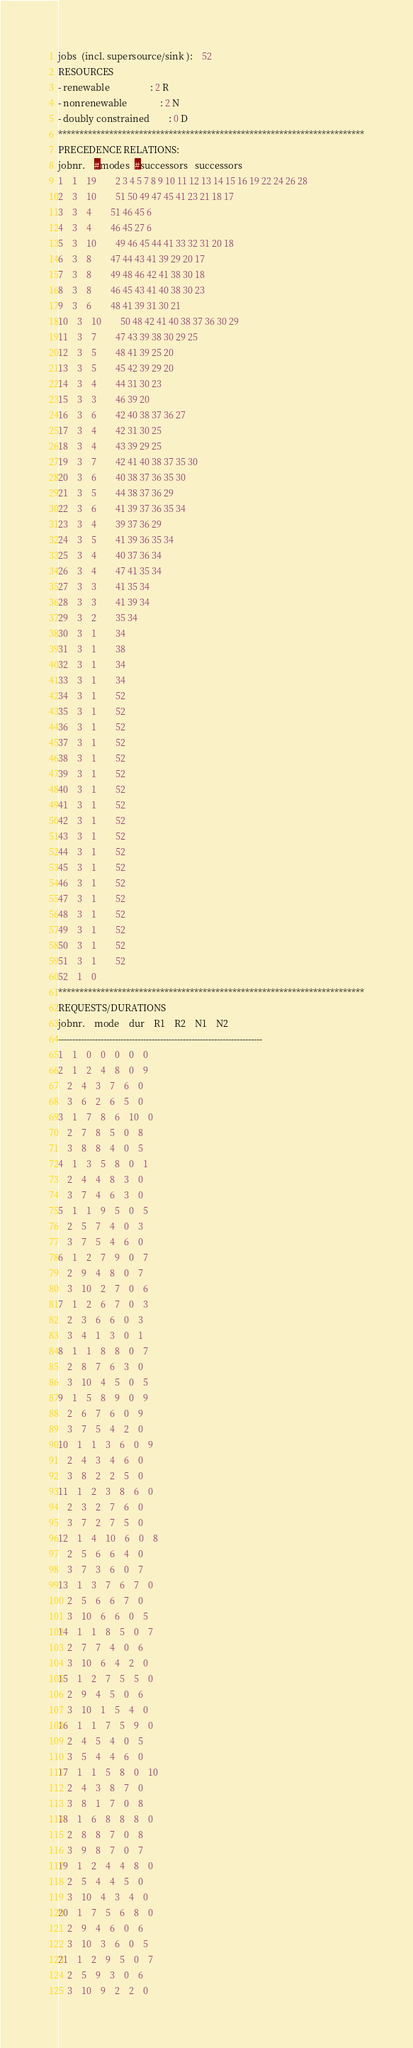<code> <loc_0><loc_0><loc_500><loc_500><_ObjectiveC_>jobs  (incl. supersource/sink ):	52
RESOURCES
- renewable                 : 2 R
- nonrenewable              : 2 N
- doubly constrained        : 0 D
************************************************************************
PRECEDENCE RELATIONS:
jobnr.    #modes  #successors   successors
1	1	19		2 3 4 5 7 8 9 10 11 12 13 14 15 16 19 22 24 26 28 
2	3	10		51 50 49 47 45 41 23 21 18 17 
3	3	4		51 46 45 6 
4	3	4		46 45 27 6 
5	3	10		49 46 45 44 41 33 32 31 20 18 
6	3	8		47 44 43 41 39 29 20 17 
7	3	8		49 48 46 42 41 38 30 18 
8	3	8		46 45 43 41 40 38 30 23 
9	3	6		48 41 39 31 30 21 
10	3	10		50 48 42 41 40 38 37 36 30 29 
11	3	7		47 43 39 38 30 29 25 
12	3	5		48 41 39 25 20 
13	3	5		45 42 39 29 20 
14	3	4		44 31 30 23 
15	3	3		46 39 20 
16	3	6		42 40 38 37 36 27 
17	3	4		42 31 30 25 
18	3	4		43 39 29 25 
19	3	7		42 41 40 38 37 35 30 
20	3	6		40 38 37 36 35 30 
21	3	5		44 38 37 36 29 
22	3	6		41 39 37 36 35 34 
23	3	4		39 37 36 29 
24	3	5		41 39 36 35 34 
25	3	4		40 37 36 34 
26	3	4		47 41 35 34 
27	3	3		41 35 34 
28	3	3		41 39 34 
29	3	2		35 34 
30	3	1		34 
31	3	1		38 
32	3	1		34 
33	3	1		34 
34	3	1		52 
35	3	1		52 
36	3	1		52 
37	3	1		52 
38	3	1		52 
39	3	1		52 
40	3	1		52 
41	3	1		52 
42	3	1		52 
43	3	1		52 
44	3	1		52 
45	3	1		52 
46	3	1		52 
47	3	1		52 
48	3	1		52 
49	3	1		52 
50	3	1		52 
51	3	1		52 
52	1	0		
************************************************************************
REQUESTS/DURATIONS
jobnr.	mode	dur	R1	R2	N1	N2	
------------------------------------------------------------------------
1	1	0	0	0	0	0	
2	1	2	4	8	0	9	
	2	4	3	7	6	0	
	3	6	2	6	5	0	
3	1	7	8	6	10	0	
	2	7	8	5	0	8	
	3	8	8	4	0	5	
4	1	3	5	8	0	1	
	2	4	4	8	3	0	
	3	7	4	6	3	0	
5	1	1	9	5	0	5	
	2	5	7	4	0	3	
	3	7	5	4	6	0	
6	1	2	7	9	0	7	
	2	9	4	8	0	7	
	3	10	2	7	0	6	
7	1	2	6	7	0	3	
	2	3	6	6	0	3	
	3	4	1	3	0	1	
8	1	1	8	8	0	7	
	2	8	7	6	3	0	
	3	10	4	5	0	5	
9	1	5	8	9	0	9	
	2	6	7	6	0	9	
	3	7	5	4	2	0	
10	1	1	3	6	0	9	
	2	4	3	4	6	0	
	3	8	2	2	5	0	
11	1	2	3	8	6	0	
	2	3	2	7	6	0	
	3	7	2	7	5	0	
12	1	4	10	6	0	8	
	2	5	6	6	4	0	
	3	7	3	6	0	7	
13	1	3	7	6	7	0	
	2	5	6	6	7	0	
	3	10	6	6	0	5	
14	1	1	8	5	0	7	
	2	7	7	4	0	6	
	3	10	6	4	2	0	
15	1	2	7	5	5	0	
	2	9	4	5	0	6	
	3	10	1	5	4	0	
16	1	1	7	5	9	0	
	2	4	5	4	0	5	
	3	5	4	4	6	0	
17	1	1	5	8	0	10	
	2	4	3	8	7	0	
	3	8	1	7	0	8	
18	1	6	8	8	8	0	
	2	8	8	7	0	8	
	3	9	8	7	0	7	
19	1	2	4	4	8	0	
	2	5	4	4	5	0	
	3	10	4	3	4	0	
20	1	7	5	6	8	0	
	2	9	4	6	0	6	
	3	10	3	6	0	5	
21	1	2	9	5	0	7	
	2	5	9	3	0	6	
	3	10	9	2	2	0	</code> 